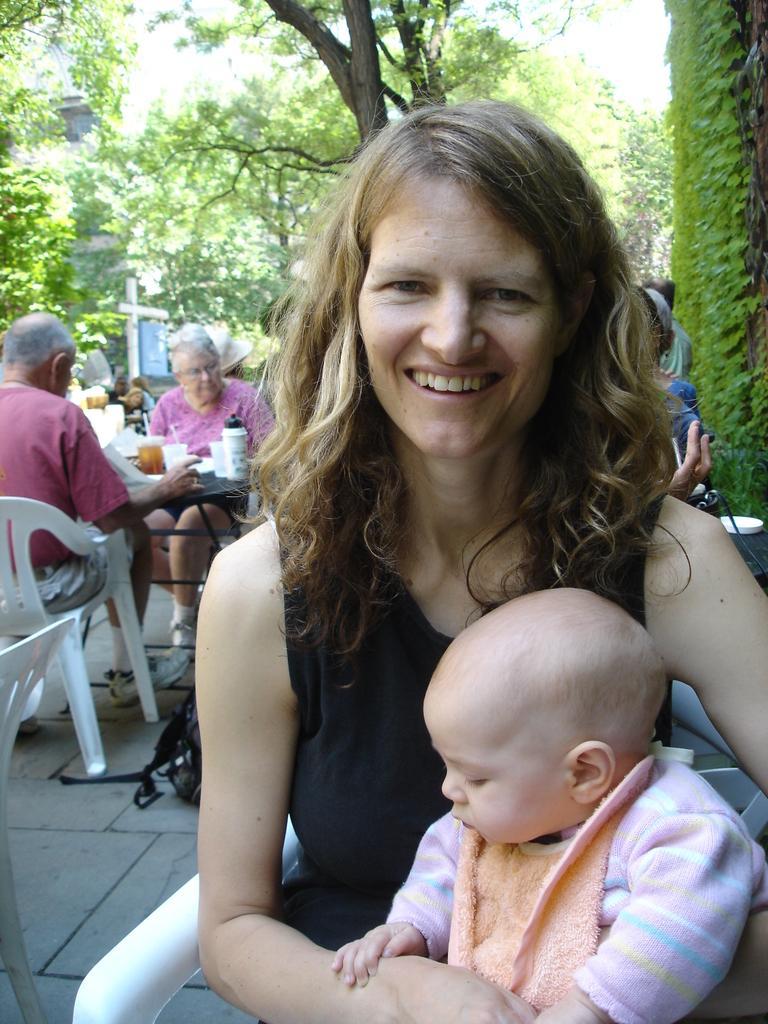Describe this image in one or two sentences. In the center of the image we can see a lady is sitting on a chair and smiling and holding a kid. In the background of the image we can see the tables, chairs. On the tables we can see the cloths, bottles, papers and other objects and some people are sitting on the chairs. In the background of the image we can see the trees, building. At the top of the image we can see the sky. On the right side of the image we can see a creeping plant. At the bottom of the image we can see the floor. 